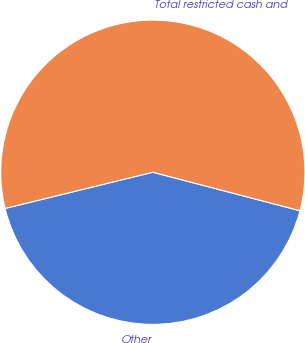<chart> <loc_0><loc_0><loc_500><loc_500><pie_chart><fcel>Other<fcel>Total restricted cash and<nl><fcel>42.1%<fcel>57.9%<nl></chart> 